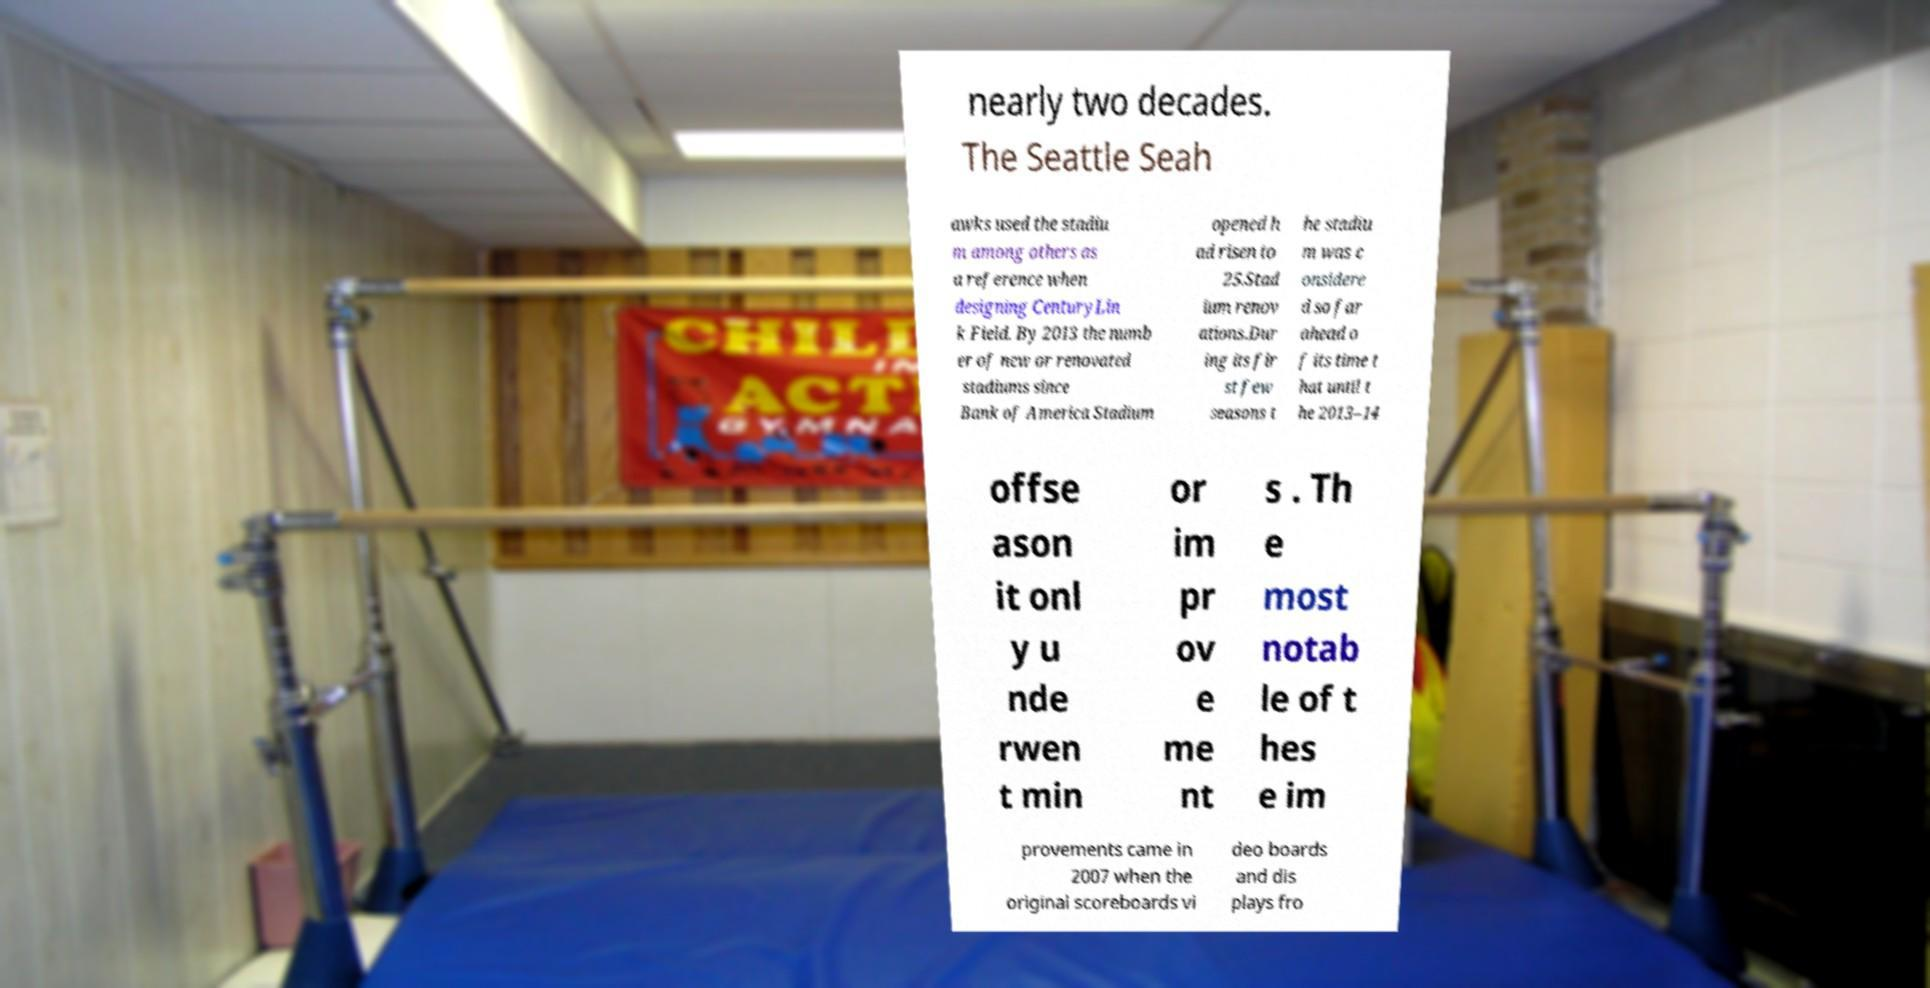For documentation purposes, I need the text within this image transcribed. Could you provide that? nearly two decades. The Seattle Seah awks used the stadiu m among others as a reference when designing CenturyLin k Field. By 2013 the numb er of new or renovated stadiums since Bank of America Stadium opened h ad risen to 25.Stad ium renov ations.Dur ing its fir st few seasons t he stadiu m was c onsidere d so far ahead o f its time t hat until t he 2013–14 offse ason it onl y u nde rwen t min or im pr ov e me nt s . Th e most notab le of t hes e im provements came in 2007 when the original scoreboards vi deo boards and dis plays fro 